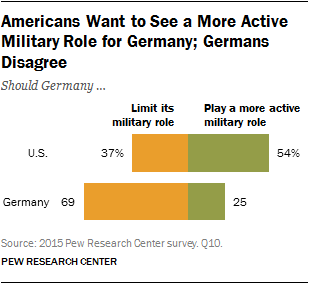Draw attention to some important aspects in this diagram. Germany intends to restrict its military involvement. Two countries limit their military role differently, with one placing a stricter limit on its involvement while the other allows for a greater degree of military activity. 